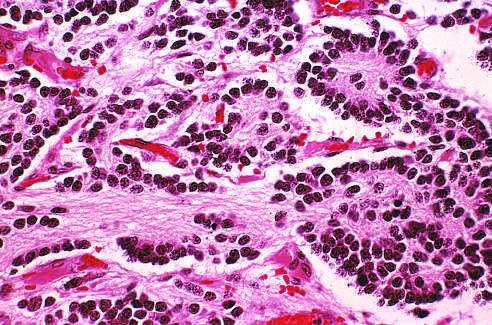s the late-phase reaction composed of small cells embedded in a finely fibrillar matrix?
Answer the question using a single word or phrase. No 